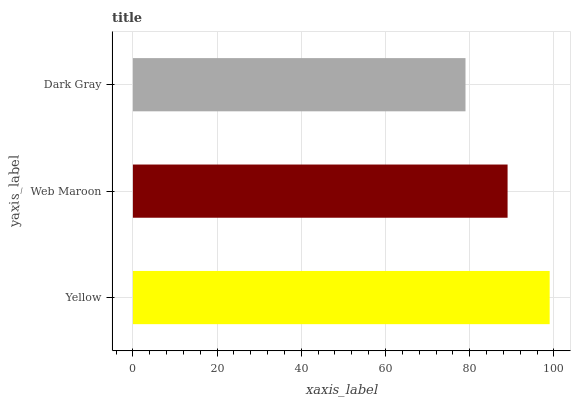Is Dark Gray the minimum?
Answer yes or no. Yes. Is Yellow the maximum?
Answer yes or no. Yes. Is Web Maroon the minimum?
Answer yes or no. No. Is Web Maroon the maximum?
Answer yes or no. No. Is Yellow greater than Web Maroon?
Answer yes or no. Yes. Is Web Maroon less than Yellow?
Answer yes or no. Yes. Is Web Maroon greater than Yellow?
Answer yes or no. No. Is Yellow less than Web Maroon?
Answer yes or no. No. Is Web Maroon the high median?
Answer yes or no. Yes. Is Web Maroon the low median?
Answer yes or no. Yes. Is Dark Gray the high median?
Answer yes or no. No. Is Dark Gray the low median?
Answer yes or no. No. 